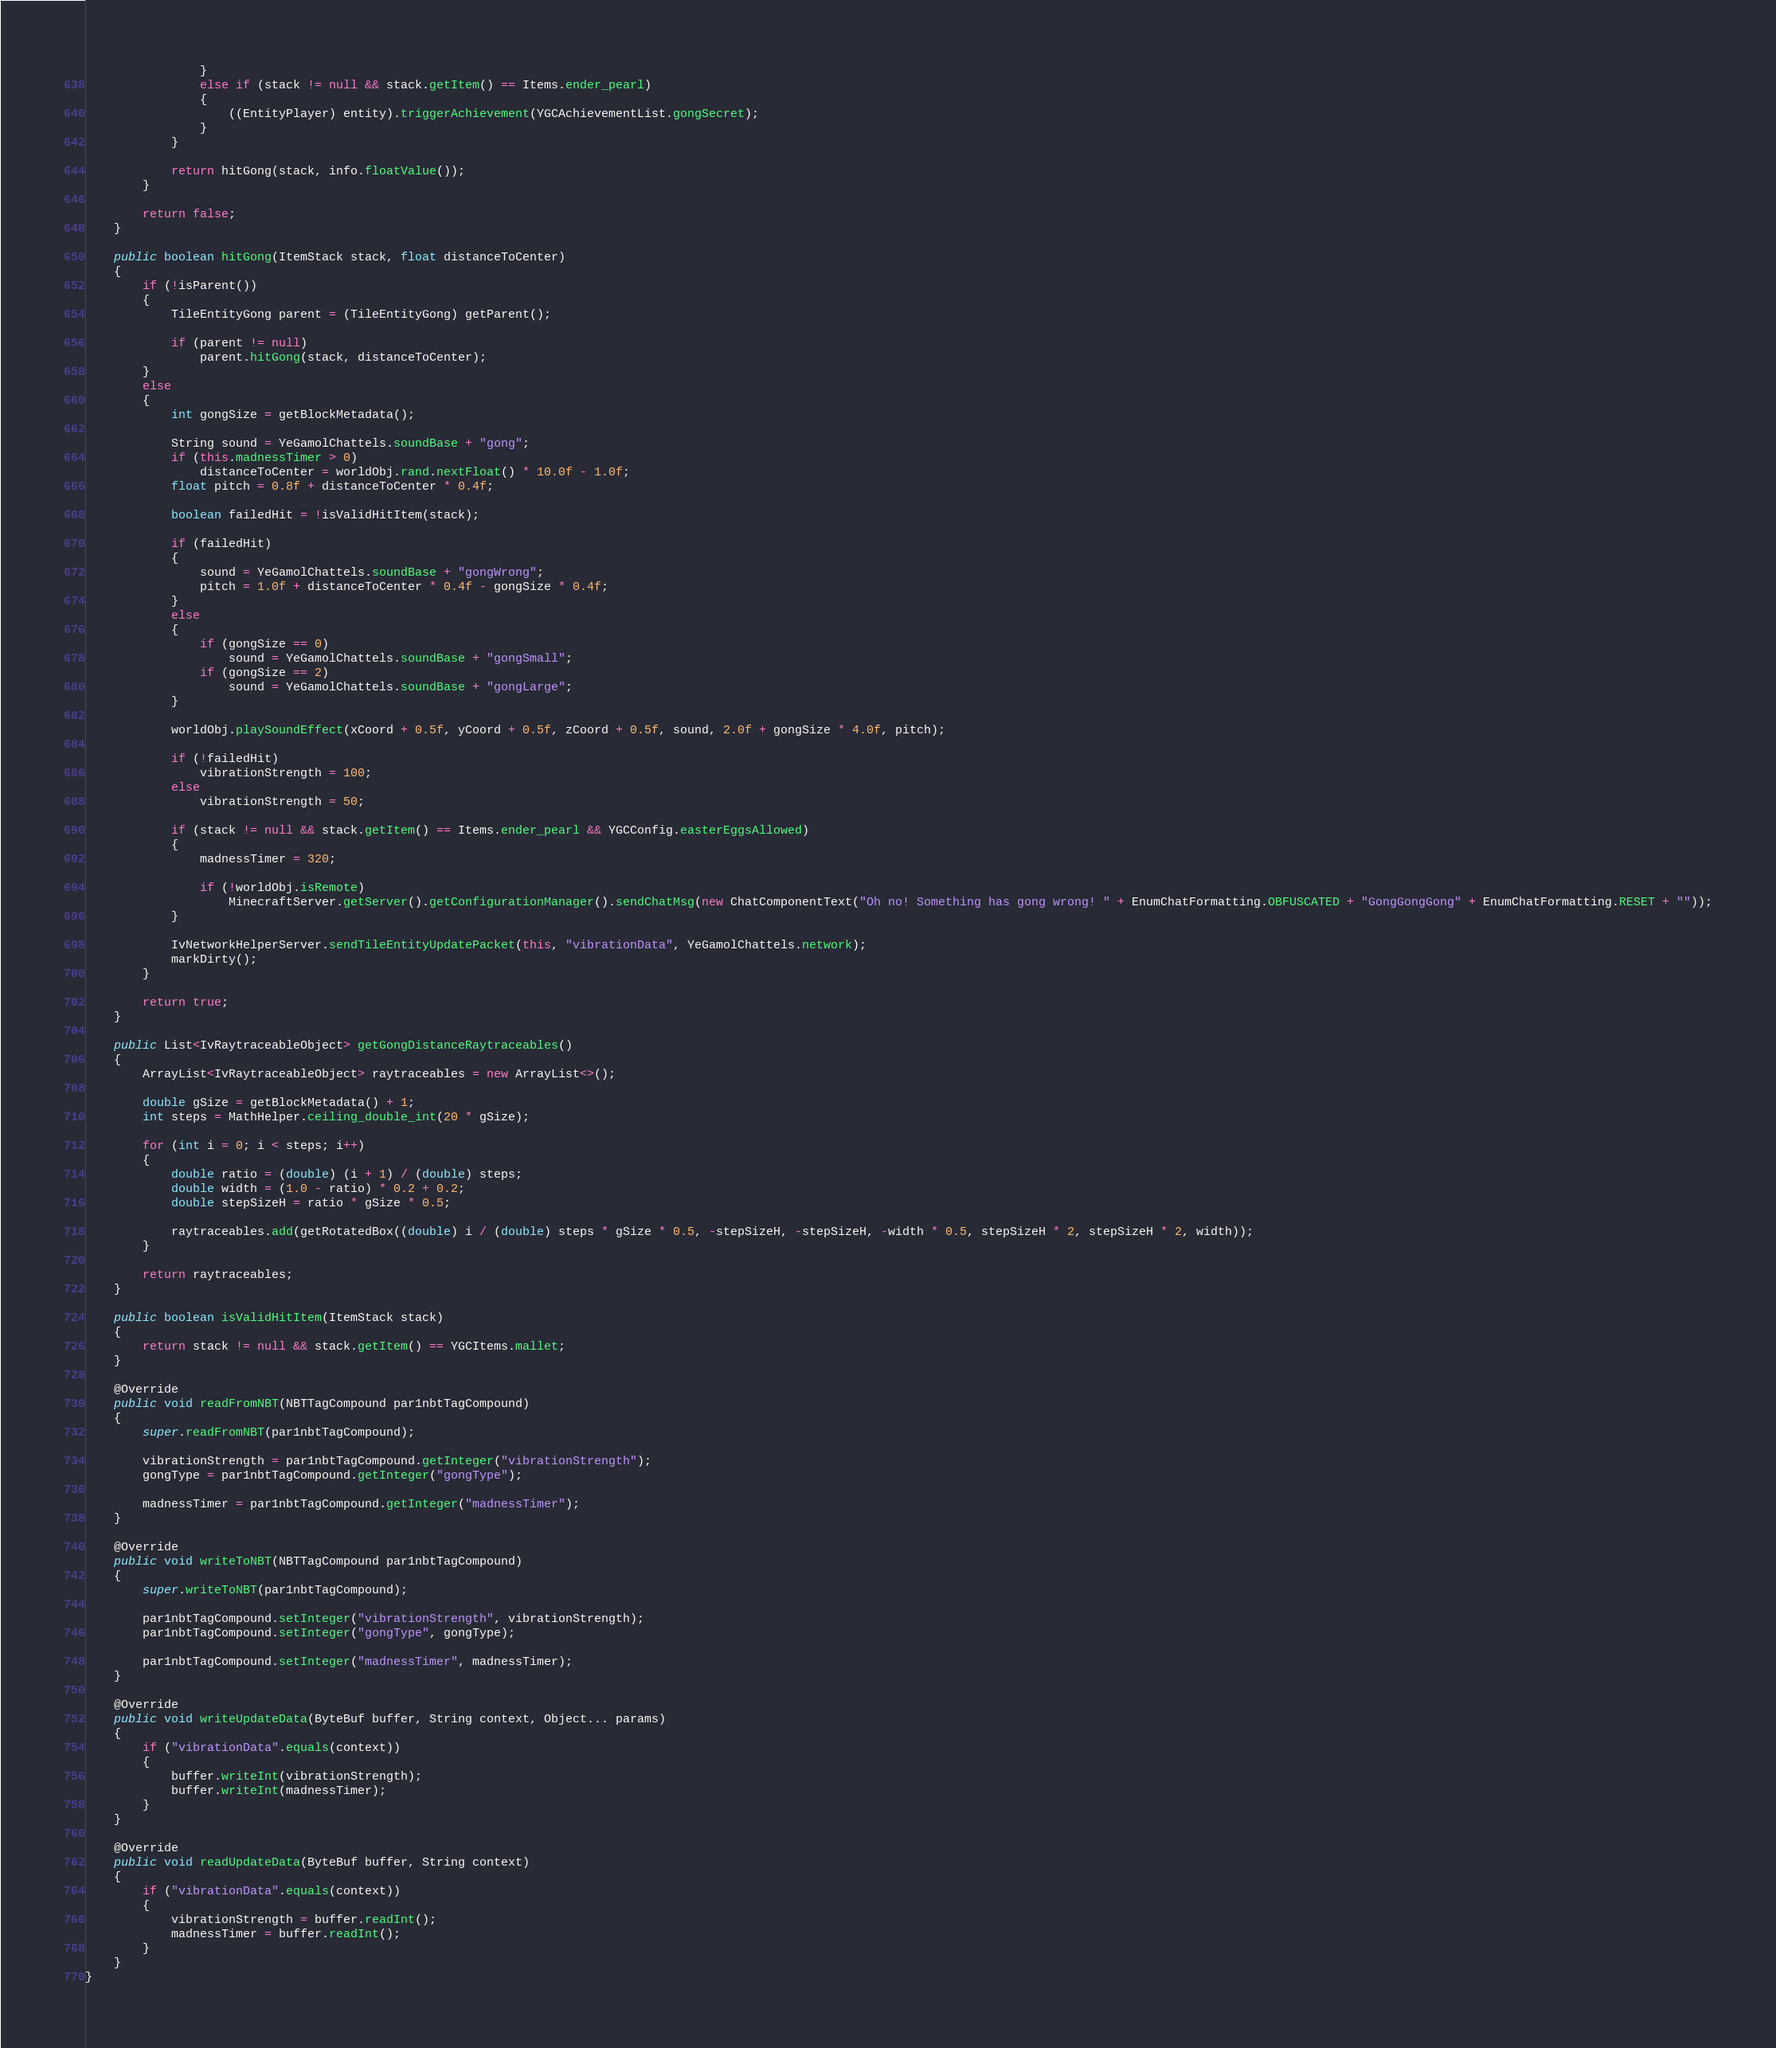<code> <loc_0><loc_0><loc_500><loc_500><_Java_>                }
                else if (stack != null && stack.getItem() == Items.ender_pearl)
                {
                    ((EntityPlayer) entity).triggerAchievement(YGCAchievementList.gongSecret);
                }
            }

            return hitGong(stack, info.floatValue());
        }

        return false;
    }

    public boolean hitGong(ItemStack stack, float distanceToCenter)
    {
        if (!isParent())
        {
            TileEntityGong parent = (TileEntityGong) getParent();

            if (parent != null)
                parent.hitGong(stack, distanceToCenter);
        }
        else
        {
            int gongSize = getBlockMetadata();

            String sound = YeGamolChattels.soundBase + "gong";
            if (this.madnessTimer > 0)
                distanceToCenter = worldObj.rand.nextFloat() * 10.0f - 1.0f;
            float pitch = 0.8f + distanceToCenter * 0.4f;

            boolean failedHit = !isValidHitItem(stack);

            if (failedHit)
            {
                sound = YeGamolChattels.soundBase + "gongWrong";
                pitch = 1.0f + distanceToCenter * 0.4f - gongSize * 0.4f;
            }
            else
            {
                if (gongSize == 0)
                    sound = YeGamolChattels.soundBase + "gongSmall";
                if (gongSize == 2)
                    sound = YeGamolChattels.soundBase + "gongLarge";
            }

            worldObj.playSoundEffect(xCoord + 0.5f, yCoord + 0.5f, zCoord + 0.5f, sound, 2.0f + gongSize * 4.0f, pitch);

            if (!failedHit)
                vibrationStrength = 100;
            else
                vibrationStrength = 50;

            if (stack != null && stack.getItem() == Items.ender_pearl && YGCConfig.easterEggsAllowed)
            {
                madnessTimer = 320;

                if (!worldObj.isRemote)
                    MinecraftServer.getServer().getConfigurationManager().sendChatMsg(new ChatComponentText("Oh no! Something has gong wrong! " + EnumChatFormatting.OBFUSCATED + "GongGongGong" + EnumChatFormatting.RESET + ""));
            }

            IvNetworkHelperServer.sendTileEntityUpdatePacket(this, "vibrationData", YeGamolChattels.network);
            markDirty();
        }

        return true;
    }

    public List<IvRaytraceableObject> getGongDistanceRaytraceables()
    {
        ArrayList<IvRaytraceableObject> raytraceables = new ArrayList<>();

        double gSize = getBlockMetadata() + 1;
        int steps = MathHelper.ceiling_double_int(20 * gSize);

        for (int i = 0; i < steps; i++)
        {
            double ratio = (double) (i + 1) / (double) steps;
            double width = (1.0 - ratio) * 0.2 + 0.2;
            double stepSizeH = ratio * gSize * 0.5;

            raytraceables.add(getRotatedBox((double) i / (double) steps * gSize * 0.5, -stepSizeH, -stepSizeH, -width * 0.5, stepSizeH * 2, stepSizeH * 2, width));
        }

        return raytraceables;
    }

    public boolean isValidHitItem(ItemStack stack)
    {
        return stack != null && stack.getItem() == YGCItems.mallet;
    }

    @Override
    public void readFromNBT(NBTTagCompound par1nbtTagCompound)
    {
        super.readFromNBT(par1nbtTagCompound);

        vibrationStrength = par1nbtTagCompound.getInteger("vibrationStrength");
        gongType = par1nbtTagCompound.getInteger("gongType");

        madnessTimer = par1nbtTagCompound.getInteger("madnessTimer");
    }

    @Override
    public void writeToNBT(NBTTagCompound par1nbtTagCompound)
    {
        super.writeToNBT(par1nbtTagCompound);

        par1nbtTagCompound.setInteger("vibrationStrength", vibrationStrength);
        par1nbtTagCompound.setInteger("gongType", gongType);

        par1nbtTagCompound.setInteger("madnessTimer", madnessTimer);
    }

    @Override
    public void writeUpdateData(ByteBuf buffer, String context, Object... params)
    {
        if ("vibrationData".equals(context))
        {
            buffer.writeInt(vibrationStrength);
            buffer.writeInt(madnessTimer);
        }
    }

    @Override
    public void readUpdateData(ByteBuf buffer, String context)
    {
        if ("vibrationData".equals(context))
        {
            vibrationStrength = buffer.readInt();
            madnessTimer = buffer.readInt();
        }
    }
}
</code> 